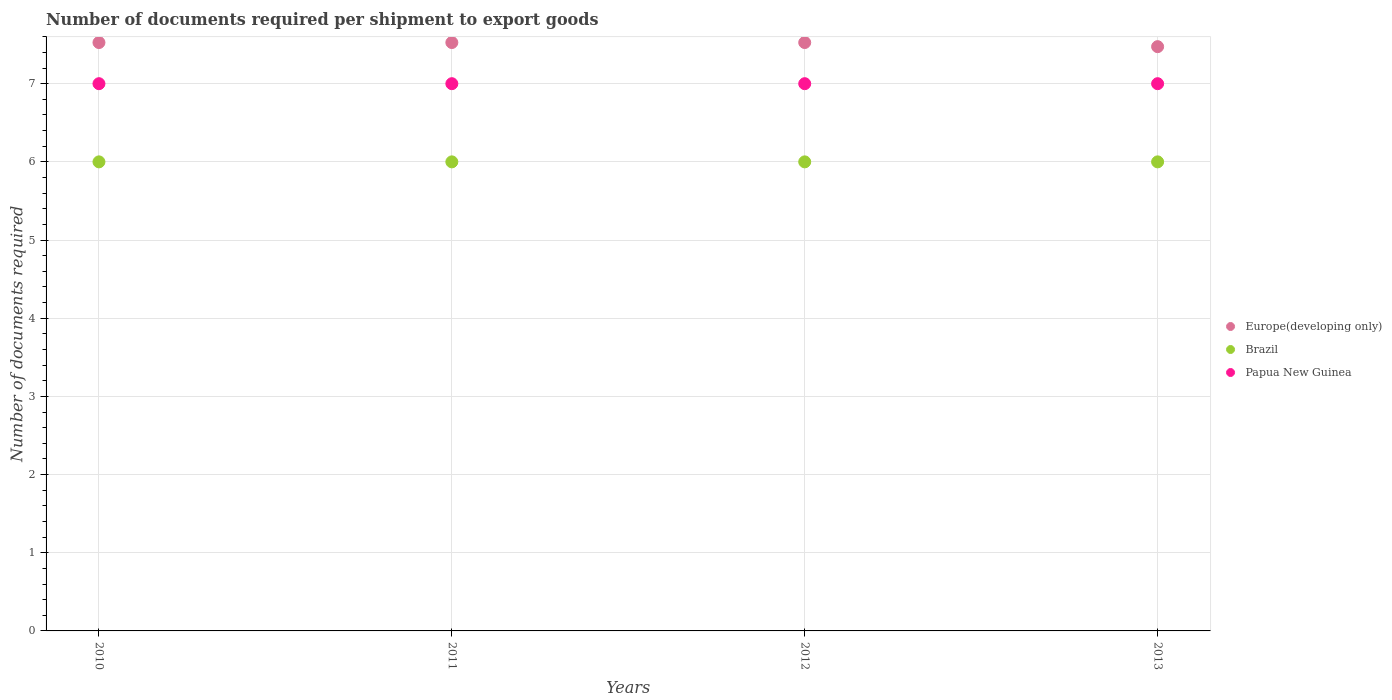How many different coloured dotlines are there?
Your response must be concise. 3. Is the number of dotlines equal to the number of legend labels?
Offer a very short reply. Yes. What is the number of documents required per shipment to export goods in Papua New Guinea in 2011?
Keep it short and to the point. 7. Across all years, what is the maximum number of documents required per shipment to export goods in Brazil?
Provide a succinct answer. 6. Across all years, what is the minimum number of documents required per shipment to export goods in Papua New Guinea?
Give a very brief answer. 7. In which year was the number of documents required per shipment to export goods in Europe(developing only) maximum?
Ensure brevity in your answer.  2010. What is the total number of documents required per shipment to export goods in Europe(developing only) in the graph?
Your answer should be compact. 30.05. What is the difference between the number of documents required per shipment to export goods in Brazil in 2010 and that in 2013?
Provide a succinct answer. 0. What is the difference between the number of documents required per shipment to export goods in Papua New Guinea in 2011 and the number of documents required per shipment to export goods in Europe(developing only) in 2012?
Provide a short and direct response. -0.53. What is the average number of documents required per shipment to export goods in Papua New Guinea per year?
Offer a very short reply. 7. In the year 2010, what is the difference between the number of documents required per shipment to export goods in Brazil and number of documents required per shipment to export goods in Papua New Guinea?
Your answer should be compact. -1. What is the ratio of the number of documents required per shipment to export goods in Papua New Guinea in 2012 to that in 2013?
Offer a terse response. 1. What is the difference between the highest and the second highest number of documents required per shipment to export goods in Europe(developing only)?
Give a very brief answer. 0. What is the difference between the highest and the lowest number of documents required per shipment to export goods in Brazil?
Give a very brief answer. 0. In how many years, is the number of documents required per shipment to export goods in Brazil greater than the average number of documents required per shipment to export goods in Brazil taken over all years?
Give a very brief answer. 0. Is it the case that in every year, the sum of the number of documents required per shipment to export goods in Papua New Guinea and number of documents required per shipment to export goods in Brazil  is greater than the number of documents required per shipment to export goods in Europe(developing only)?
Your response must be concise. Yes. Does the number of documents required per shipment to export goods in Brazil monotonically increase over the years?
Keep it short and to the point. No. What is the difference between two consecutive major ticks on the Y-axis?
Offer a terse response. 1. Where does the legend appear in the graph?
Give a very brief answer. Center right. How many legend labels are there?
Your answer should be very brief. 3. How are the legend labels stacked?
Offer a terse response. Vertical. What is the title of the graph?
Make the answer very short. Number of documents required per shipment to export goods. Does "Central African Republic" appear as one of the legend labels in the graph?
Keep it short and to the point. No. What is the label or title of the X-axis?
Provide a succinct answer. Years. What is the label or title of the Y-axis?
Offer a terse response. Number of documents required. What is the Number of documents required in Europe(developing only) in 2010?
Keep it short and to the point. 7.53. What is the Number of documents required of Brazil in 2010?
Your answer should be compact. 6. What is the Number of documents required in Papua New Guinea in 2010?
Your answer should be compact. 7. What is the Number of documents required in Europe(developing only) in 2011?
Keep it short and to the point. 7.53. What is the Number of documents required of Papua New Guinea in 2011?
Offer a very short reply. 7. What is the Number of documents required in Europe(developing only) in 2012?
Provide a succinct answer. 7.53. What is the Number of documents required of Brazil in 2012?
Offer a very short reply. 6. What is the Number of documents required in Papua New Guinea in 2012?
Offer a very short reply. 7. What is the Number of documents required of Europe(developing only) in 2013?
Your response must be concise. 7.47. What is the Number of documents required in Papua New Guinea in 2013?
Provide a succinct answer. 7. Across all years, what is the maximum Number of documents required in Europe(developing only)?
Your answer should be very brief. 7.53. Across all years, what is the maximum Number of documents required in Papua New Guinea?
Keep it short and to the point. 7. Across all years, what is the minimum Number of documents required of Europe(developing only)?
Make the answer very short. 7.47. What is the total Number of documents required in Europe(developing only) in the graph?
Ensure brevity in your answer.  30.05. What is the total Number of documents required in Brazil in the graph?
Your answer should be very brief. 24. What is the total Number of documents required of Papua New Guinea in the graph?
Provide a succinct answer. 28. What is the difference between the Number of documents required in Brazil in 2010 and that in 2012?
Make the answer very short. 0. What is the difference between the Number of documents required in Papua New Guinea in 2010 and that in 2012?
Your response must be concise. 0. What is the difference between the Number of documents required of Europe(developing only) in 2010 and that in 2013?
Ensure brevity in your answer.  0.05. What is the difference between the Number of documents required in Papua New Guinea in 2010 and that in 2013?
Provide a short and direct response. 0. What is the difference between the Number of documents required of Europe(developing only) in 2011 and that in 2012?
Make the answer very short. 0. What is the difference between the Number of documents required of Brazil in 2011 and that in 2012?
Ensure brevity in your answer.  0. What is the difference between the Number of documents required of Papua New Guinea in 2011 and that in 2012?
Give a very brief answer. 0. What is the difference between the Number of documents required of Europe(developing only) in 2011 and that in 2013?
Provide a short and direct response. 0.05. What is the difference between the Number of documents required of Papua New Guinea in 2011 and that in 2013?
Your answer should be compact. 0. What is the difference between the Number of documents required of Europe(developing only) in 2012 and that in 2013?
Your response must be concise. 0.05. What is the difference between the Number of documents required in Papua New Guinea in 2012 and that in 2013?
Keep it short and to the point. 0. What is the difference between the Number of documents required of Europe(developing only) in 2010 and the Number of documents required of Brazil in 2011?
Your response must be concise. 1.53. What is the difference between the Number of documents required in Europe(developing only) in 2010 and the Number of documents required in Papua New Guinea in 2011?
Your answer should be very brief. 0.53. What is the difference between the Number of documents required of Brazil in 2010 and the Number of documents required of Papua New Guinea in 2011?
Your answer should be compact. -1. What is the difference between the Number of documents required of Europe(developing only) in 2010 and the Number of documents required of Brazil in 2012?
Provide a succinct answer. 1.53. What is the difference between the Number of documents required of Europe(developing only) in 2010 and the Number of documents required of Papua New Guinea in 2012?
Offer a very short reply. 0.53. What is the difference between the Number of documents required of Brazil in 2010 and the Number of documents required of Papua New Guinea in 2012?
Your answer should be compact. -1. What is the difference between the Number of documents required in Europe(developing only) in 2010 and the Number of documents required in Brazil in 2013?
Your answer should be very brief. 1.53. What is the difference between the Number of documents required in Europe(developing only) in 2010 and the Number of documents required in Papua New Guinea in 2013?
Provide a succinct answer. 0.53. What is the difference between the Number of documents required of Europe(developing only) in 2011 and the Number of documents required of Brazil in 2012?
Your answer should be compact. 1.53. What is the difference between the Number of documents required of Europe(developing only) in 2011 and the Number of documents required of Papua New Guinea in 2012?
Offer a very short reply. 0.53. What is the difference between the Number of documents required in Brazil in 2011 and the Number of documents required in Papua New Guinea in 2012?
Keep it short and to the point. -1. What is the difference between the Number of documents required in Europe(developing only) in 2011 and the Number of documents required in Brazil in 2013?
Provide a short and direct response. 1.53. What is the difference between the Number of documents required in Europe(developing only) in 2011 and the Number of documents required in Papua New Guinea in 2013?
Offer a very short reply. 0.53. What is the difference between the Number of documents required in Brazil in 2011 and the Number of documents required in Papua New Guinea in 2013?
Give a very brief answer. -1. What is the difference between the Number of documents required in Europe(developing only) in 2012 and the Number of documents required in Brazil in 2013?
Provide a succinct answer. 1.53. What is the difference between the Number of documents required of Europe(developing only) in 2012 and the Number of documents required of Papua New Guinea in 2013?
Offer a very short reply. 0.53. What is the average Number of documents required of Europe(developing only) per year?
Offer a very short reply. 7.51. What is the average Number of documents required in Brazil per year?
Provide a succinct answer. 6. What is the average Number of documents required of Papua New Guinea per year?
Your answer should be very brief. 7. In the year 2010, what is the difference between the Number of documents required in Europe(developing only) and Number of documents required in Brazil?
Offer a very short reply. 1.53. In the year 2010, what is the difference between the Number of documents required in Europe(developing only) and Number of documents required in Papua New Guinea?
Your answer should be compact. 0.53. In the year 2010, what is the difference between the Number of documents required of Brazil and Number of documents required of Papua New Guinea?
Ensure brevity in your answer.  -1. In the year 2011, what is the difference between the Number of documents required of Europe(developing only) and Number of documents required of Brazil?
Keep it short and to the point. 1.53. In the year 2011, what is the difference between the Number of documents required in Europe(developing only) and Number of documents required in Papua New Guinea?
Your answer should be compact. 0.53. In the year 2011, what is the difference between the Number of documents required of Brazil and Number of documents required of Papua New Guinea?
Provide a short and direct response. -1. In the year 2012, what is the difference between the Number of documents required of Europe(developing only) and Number of documents required of Brazil?
Offer a very short reply. 1.53. In the year 2012, what is the difference between the Number of documents required of Europe(developing only) and Number of documents required of Papua New Guinea?
Offer a very short reply. 0.53. In the year 2012, what is the difference between the Number of documents required in Brazil and Number of documents required in Papua New Guinea?
Provide a short and direct response. -1. In the year 2013, what is the difference between the Number of documents required in Europe(developing only) and Number of documents required in Brazil?
Give a very brief answer. 1.47. In the year 2013, what is the difference between the Number of documents required of Europe(developing only) and Number of documents required of Papua New Guinea?
Your answer should be very brief. 0.47. In the year 2013, what is the difference between the Number of documents required in Brazil and Number of documents required in Papua New Guinea?
Keep it short and to the point. -1. What is the ratio of the Number of documents required in Europe(developing only) in 2010 to that in 2012?
Your answer should be very brief. 1. What is the ratio of the Number of documents required in Brazil in 2010 to that in 2012?
Give a very brief answer. 1. What is the ratio of the Number of documents required of Papua New Guinea in 2010 to that in 2012?
Keep it short and to the point. 1. What is the ratio of the Number of documents required in Europe(developing only) in 2010 to that in 2013?
Your answer should be compact. 1.01. What is the ratio of the Number of documents required of Brazil in 2010 to that in 2013?
Ensure brevity in your answer.  1. What is the ratio of the Number of documents required of Papua New Guinea in 2010 to that in 2013?
Your answer should be compact. 1. What is the ratio of the Number of documents required in Europe(developing only) in 2011 to that in 2012?
Your answer should be very brief. 1. What is the ratio of the Number of documents required in Papua New Guinea in 2011 to that in 2012?
Give a very brief answer. 1. What is the ratio of the Number of documents required in Europe(developing only) in 2011 to that in 2013?
Give a very brief answer. 1.01. What is the ratio of the Number of documents required of Brazil in 2011 to that in 2013?
Offer a very short reply. 1. What is the ratio of the Number of documents required of Papua New Guinea in 2011 to that in 2013?
Your response must be concise. 1. What is the ratio of the Number of documents required in Europe(developing only) in 2012 to that in 2013?
Provide a short and direct response. 1.01. What is the ratio of the Number of documents required in Papua New Guinea in 2012 to that in 2013?
Make the answer very short. 1. What is the difference between the highest and the second highest Number of documents required of Europe(developing only)?
Provide a short and direct response. 0. What is the difference between the highest and the lowest Number of documents required in Europe(developing only)?
Offer a very short reply. 0.05. 